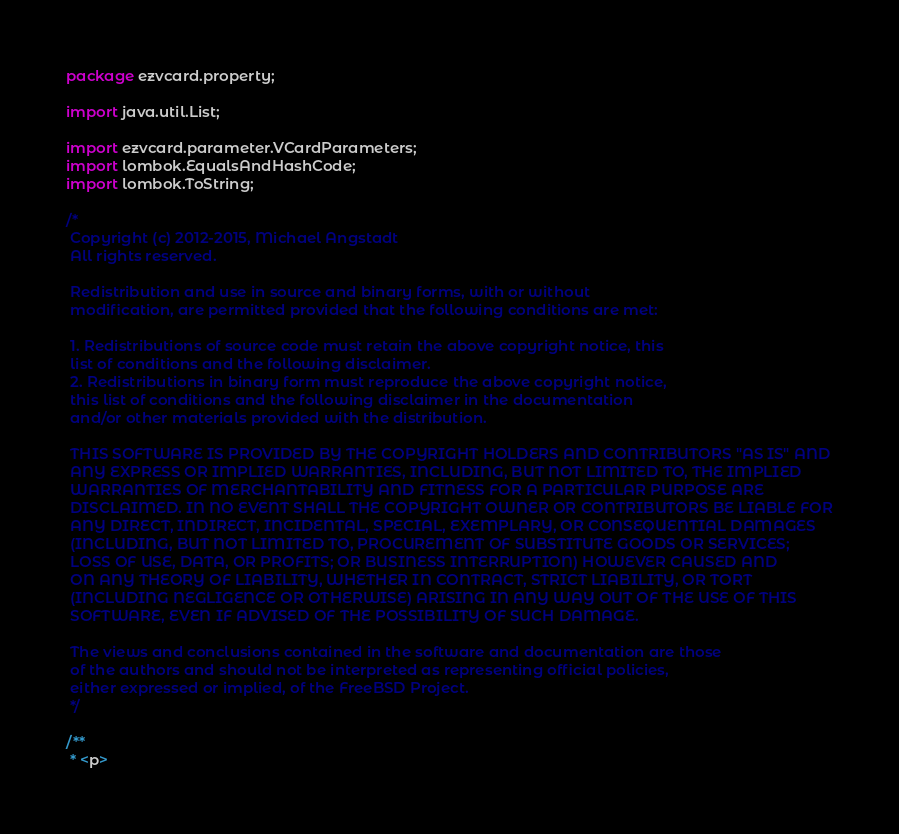<code> <loc_0><loc_0><loc_500><loc_500><_Java_>package ezvcard.property;

import java.util.List;

import ezvcard.parameter.VCardParameters;
import lombok.EqualsAndHashCode;
import lombok.ToString;

/*
 Copyright (c) 2012-2015, Michael Angstadt
 All rights reserved.

 Redistribution and use in source and binary forms, with or without
 modification, are permitted provided that the following conditions are met: 

 1. Redistributions of source code must retain the above copyright notice, this
 list of conditions and the following disclaimer. 
 2. Redistributions in binary form must reproduce the above copyright notice,
 this list of conditions and the following disclaimer in the documentation
 and/or other materials provided with the distribution. 

 THIS SOFTWARE IS PROVIDED BY THE COPYRIGHT HOLDERS AND CONTRIBUTORS "AS IS" AND
 ANY EXPRESS OR IMPLIED WARRANTIES, INCLUDING, BUT NOT LIMITED TO, THE IMPLIED
 WARRANTIES OF MERCHANTABILITY AND FITNESS FOR A PARTICULAR PURPOSE ARE
 DISCLAIMED. IN NO EVENT SHALL THE COPYRIGHT OWNER OR CONTRIBUTORS BE LIABLE FOR
 ANY DIRECT, INDIRECT, INCIDENTAL, SPECIAL, EXEMPLARY, OR CONSEQUENTIAL DAMAGES
 (INCLUDING, BUT NOT LIMITED TO, PROCUREMENT OF SUBSTITUTE GOODS OR SERVICES;
 LOSS OF USE, DATA, OR PROFITS; OR BUSINESS INTERRUPTION) HOWEVER CAUSED AND
 ON ANY THEORY OF LIABILITY, WHETHER IN CONTRACT, STRICT LIABILITY, OR TORT
 (INCLUDING NEGLIGENCE OR OTHERWISE) ARISING IN ANY WAY OUT OF THE USE OF THIS
 SOFTWARE, EVEN IF ADVISED OF THE POSSIBILITY OF SUCH DAMAGE.

 The views and conclusions contained in the software and documentation are those
 of the authors and should not be interpreted as representing official policies, 
 either expressed or implied, of the FreeBSD Project.
 */

/**
 * <p></code> 